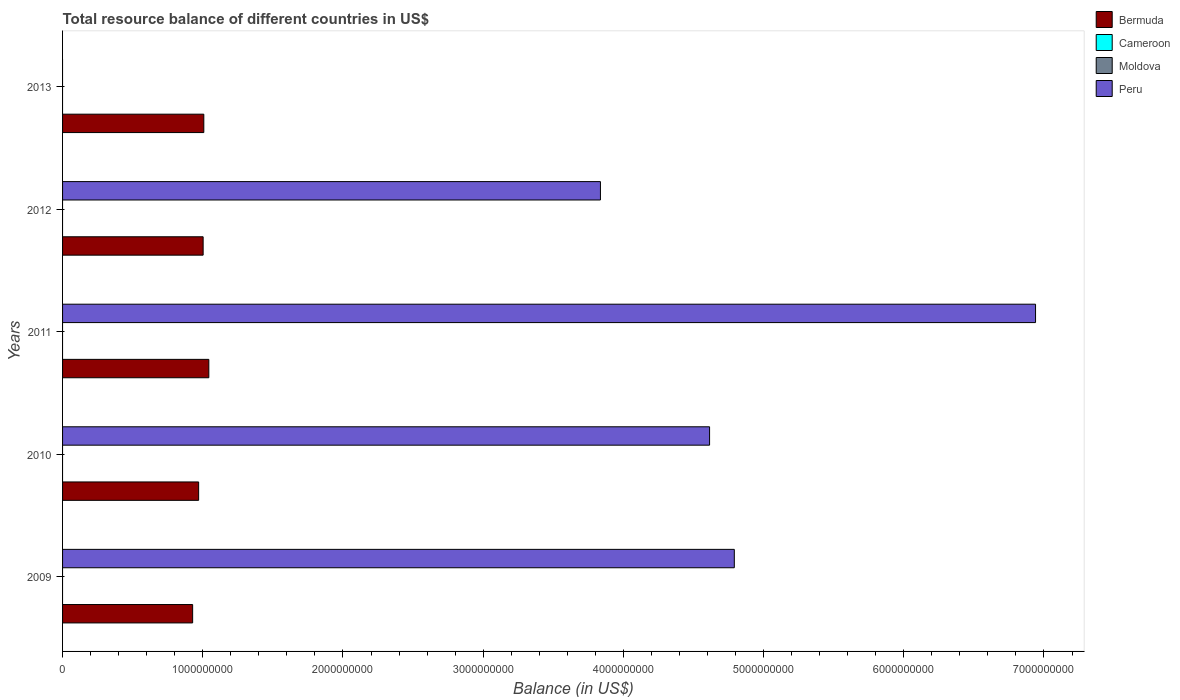How many different coloured bars are there?
Make the answer very short. 2. Are the number of bars per tick equal to the number of legend labels?
Your answer should be compact. No. How many bars are there on the 2nd tick from the top?
Offer a terse response. 2. In how many cases, is the number of bars for a given year not equal to the number of legend labels?
Provide a short and direct response. 5. What is the total resource balance in Bermuda in 2009?
Your answer should be very brief. 9.28e+08. Across all years, what is the maximum total resource balance in Bermuda?
Offer a terse response. 1.04e+09. What is the total total resource balance in Cameroon in the graph?
Your answer should be very brief. 0. What is the difference between the total resource balance in Peru in 2009 and that in 2012?
Provide a succinct answer. 9.55e+08. What is the difference between the total resource balance in Peru in 2010 and the total resource balance in Moldova in 2012?
Your response must be concise. 4.61e+09. What is the average total resource balance in Peru per year?
Your answer should be very brief. 4.04e+09. In the year 2012, what is the difference between the total resource balance in Bermuda and total resource balance in Peru?
Offer a terse response. -2.83e+09. In how many years, is the total resource balance in Peru greater than 3800000000 US$?
Give a very brief answer. 4. What is the ratio of the total resource balance in Peru in 2009 to that in 2012?
Your answer should be compact. 1.25. Is the total resource balance in Peru in 2010 less than that in 2012?
Offer a very short reply. No. What is the difference between the highest and the second highest total resource balance in Bermuda?
Provide a short and direct response. 3.57e+07. What is the difference between the highest and the lowest total resource balance in Bermuda?
Offer a very short reply. 1.15e+08. In how many years, is the total resource balance in Moldova greater than the average total resource balance in Moldova taken over all years?
Your response must be concise. 0. Is the sum of the total resource balance in Peru in 2009 and 2012 greater than the maximum total resource balance in Cameroon across all years?
Ensure brevity in your answer.  Yes. Is it the case that in every year, the sum of the total resource balance in Bermuda and total resource balance in Moldova is greater than the sum of total resource balance in Cameroon and total resource balance in Peru?
Your answer should be very brief. No. Is it the case that in every year, the sum of the total resource balance in Bermuda and total resource balance in Cameroon is greater than the total resource balance in Peru?
Offer a very short reply. No. How many bars are there?
Your answer should be very brief. 9. Are all the bars in the graph horizontal?
Provide a succinct answer. Yes. Are the values on the major ticks of X-axis written in scientific E-notation?
Your answer should be very brief. No. Does the graph contain grids?
Provide a short and direct response. No. How many legend labels are there?
Your answer should be compact. 4. How are the legend labels stacked?
Provide a short and direct response. Vertical. What is the title of the graph?
Your answer should be compact. Total resource balance of different countries in US$. Does "Swaziland" appear as one of the legend labels in the graph?
Make the answer very short. No. What is the label or title of the X-axis?
Provide a succinct answer. Balance (in US$). What is the Balance (in US$) in Bermuda in 2009?
Make the answer very short. 9.28e+08. What is the Balance (in US$) of Moldova in 2009?
Ensure brevity in your answer.  0. What is the Balance (in US$) in Peru in 2009?
Provide a succinct answer. 4.79e+09. What is the Balance (in US$) in Bermuda in 2010?
Offer a terse response. 9.71e+08. What is the Balance (in US$) in Cameroon in 2010?
Provide a succinct answer. 0. What is the Balance (in US$) in Moldova in 2010?
Give a very brief answer. 0. What is the Balance (in US$) in Peru in 2010?
Make the answer very short. 4.61e+09. What is the Balance (in US$) in Bermuda in 2011?
Your answer should be compact. 1.04e+09. What is the Balance (in US$) of Moldova in 2011?
Your response must be concise. 0. What is the Balance (in US$) in Peru in 2011?
Your answer should be compact. 6.94e+09. What is the Balance (in US$) in Bermuda in 2012?
Keep it short and to the point. 1.00e+09. What is the Balance (in US$) in Cameroon in 2012?
Your response must be concise. 0. What is the Balance (in US$) in Moldova in 2012?
Make the answer very short. 0. What is the Balance (in US$) in Peru in 2012?
Offer a terse response. 3.84e+09. What is the Balance (in US$) of Bermuda in 2013?
Provide a short and direct response. 1.01e+09. What is the Balance (in US$) in Cameroon in 2013?
Ensure brevity in your answer.  0. What is the Balance (in US$) of Peru in 2013?
Your answer should be compact. 0. Across all years, what is the maximum Balance (in US$) in Bermuda?
Ensure brevity in your answer.  1.04e+09. Across all years, what is the maximum Balance (in US$) of Peru?
Your answer should be very brief. 6.94e+09. Across all years, what is the minimum Balance (in US$) of Bermuda?
Keep it short and to the point. 9.28e+08. What is the total Balance (in US$) in Bermuda in the graph?
Make the answer very short. 4.95e+09. What is the total Balance (in US$) of Cameroon in the graph?
Your response must be concise. 0. What is the total Balance (in US$) of Moldova in the graph?
Give a very brief answer. 0. What is the total Balance (in US$) in Peru in the graph?
Offer a terse response. 2.02e+1. What is the difference between the Balance (in US$) of Bermuda in 2009 and that in 2010?
Your response must be concise. -4.29e+07. What is the difference between the Balance (in US$) of Peru in 2009 and that in 2010?
Provide a short and direct response. 1.76e+08. What is the difference between the Balance (in US$) in Bermuda in 2009 and that in 2011?
Make the answer very short. -1.15e+08. What is the difference between the Balance (in US$) of Peru in 2009 and that in 2011?
Give a very brief answer. -2.15e+09. What is the difference between the Balance (in US$) in Bermuda in 2009 and that in 2012?
Your answer should be compact. -7.49e+07. What is the difference between the Balance (in US$) in Peru in 2009 and that in 2012?
Provide a succinct answer. 9.55e+08. What is the difference between the Balance (in US$) in Bermuda in 2009 and that in 2013?
Provide a succinct answer. -7.98e+07. What is the difference between the Balance (in US$) of Bermuda in 2010 and that in 2011?
Ensure brevity in your answer.  -7.26e+07. What is the difference between the Balance (in US$) of Peru in 2010 and that in 2011?
Your answer should be very brief. -2.33e+09. What is the difference between the Balance (in US$) in Bermuda in 2010 and that in 2012?
Keep it short and to the point. -3.20e+07. What is the difference between the Balance (in US$) in Peru in 2010 and that in 2012?
Offer a very short reply. 7.78e+08. What is the difference between the Balance (in US$) of Bermuda in 2010 and that in 2013?
Keep it short and to the point. -3.69e+07. What is the difference between the Balance (in US$) of Bermuda in 2011 and that in 2012?
Make the answer very short. 4.06e+07. What is the difference between the Balance (in US$) of Peru in 2011 and that in 2012?
Give a very brief answer. 3.10e+09. What is the difference between the Balance (in US$) in Bermuda in 2011 and that in 2013?
Ensure brevity in your answer.  3.57e+07. What is the difference between the Balance (in US$) of Bermuda in 2012 and that in 2013?
Keep it short and to the point. -4.84e+06. What is the difference between the Balance (in US$) of Bermuda in 2009 and the Balance (in US$) of Peru in 2010?
Offer a terse response. -3.69e+09. What is the difference between the Balance (in US$) in Bermuda in 2009 and the Balance (in US$) in Peru in 2011?
Provide a succinct answer. -6.01e+09. What is the difference between the Balance (in US$) of Bermuda in 2009 and the Balance (in US$) of Peru in 2012?
Your answer should be compact. -2.91e+09. What is the difference between the Balance (in US$) of Bermuda in 2010 and the Balance (in US$) of Peru in 2011?
Ensure brevity in your answer.  -5.97e+09. What is the difference between the Balance (in US$) of Bermuda in 2010 and the Balance (in US$) of Peru in 2012?
Offer a terse response. -2.87e+09. What is the difference between the Balance (in US$) in Bermuda in 2011 and the Balance (in US$) in Peru in 2012?
Provide a succinct answer. -2.79e+09. What is the average Balance (in US$) of Bermuda per year?
Make the answer very short. 9.90e+08. What is the average Balance (in US$) of Moldova per year?
Make the answer very short. 0. What is the average Balance (in US$) of Peru per year?
Your answer should be compact. 4.04e+09. In the year 2009, what is the difference between the Balance (in US$) in Bermuda and Balance (in US$) in Peru?
Your answer should be compact. -3.86e+09. In the year 2010, what is the difference between the Balance (in US$) in Bermuda and Balance (in US$) in Peru?
Provide a short and direct response. -3.64e+09. In the year 2011, what is the difference between the Balance (in US$) in Bermuda and Balance (in US$) in Peru?
Your answer should be very brief. -5.90e+09. In the year 2012, what is the difference between the Balance (in US$) in Bermuda and Balance (in US$) in Peru?
Keep it short and to the point. -2.83e+09. What is the ratio of the Balance (in US$) of Bermuda in 2009 to that in 2010?
Offer a very short reply. 0.96. What is the ratio of the Balance (in US$) of Peru in 2009 to that in 2010?
Give a very brief answer. 1.04. What is the ratio of the Balance (in US$) in Bermuda in 2009 to that in 2011?
Offer a very short reply. 0.89. What is the ratio of the Balance (in US$) of Peru in 2009 to that in 2011?
Give a very brief answer. 0.69. What is the ratio of the Balance (in US$) of Bermuda in 2009 to that in 2012?
Your answer should be compact. 0.93. What is the ratio of the Balance (in US$) of Peru in 2009 to that in 2012?
Your answer should be compact. 1.25. What is the ratio of the Balance (in US$) in Bermuda in 2009 to that in 2013?
Offer a very short reply. 0.92. What is the ratio of the Balance (in US$) of Bermuda in 2010 to that in 2011?
Offer a terse response. 0.93. What is the ratio of the Balance (in US$) in Peru in 2010 to that in 2011?
Ensure brevity in your answer.  0.67. What is the ratio of the Balance (in US$) of Bermuda in 2010 to that in 2012?
Make the answer very short. 0.97. What is the ratio of the Balance (in US$) of Peru in 2010 to that in 2012?
Your response must be concise. 1.2. What is the ratio of the Balance (in US$) of Bermuda in 2010 to that in 2013?
Offer a very short reply. 0.96. What is the ratio of the Balance (in US$) in Bermuda in 2011 to that in 2012?
Make the answer very short. 1.04. What is the ratio of the Balance (in US$) in Peru in 2011 to that in 2012?
Offer a very short reply. 1.81. What is the ratio of the Balance (in US$) of Bermuda in 2011 to that in 2013?
Your response must be concise. 1.04. What is the difference between the highest and the second highest Balance (in US$) of Bermuda?
Offer a very short reply. 3.57e+07. What is the difference between the highest and the second highest Balance (in US$) in Peru?
Ensure brevity in your answer.  2.15e+09. What is the difference between the highest and the lowest Balance (in US$) of Bermuda?
Ensure brevity in your answer.  1.15e+08. What is the difference between the highest and the lowest Balance (in US$) in Peru?
Provide a short and direct response. 6.94e+09. 